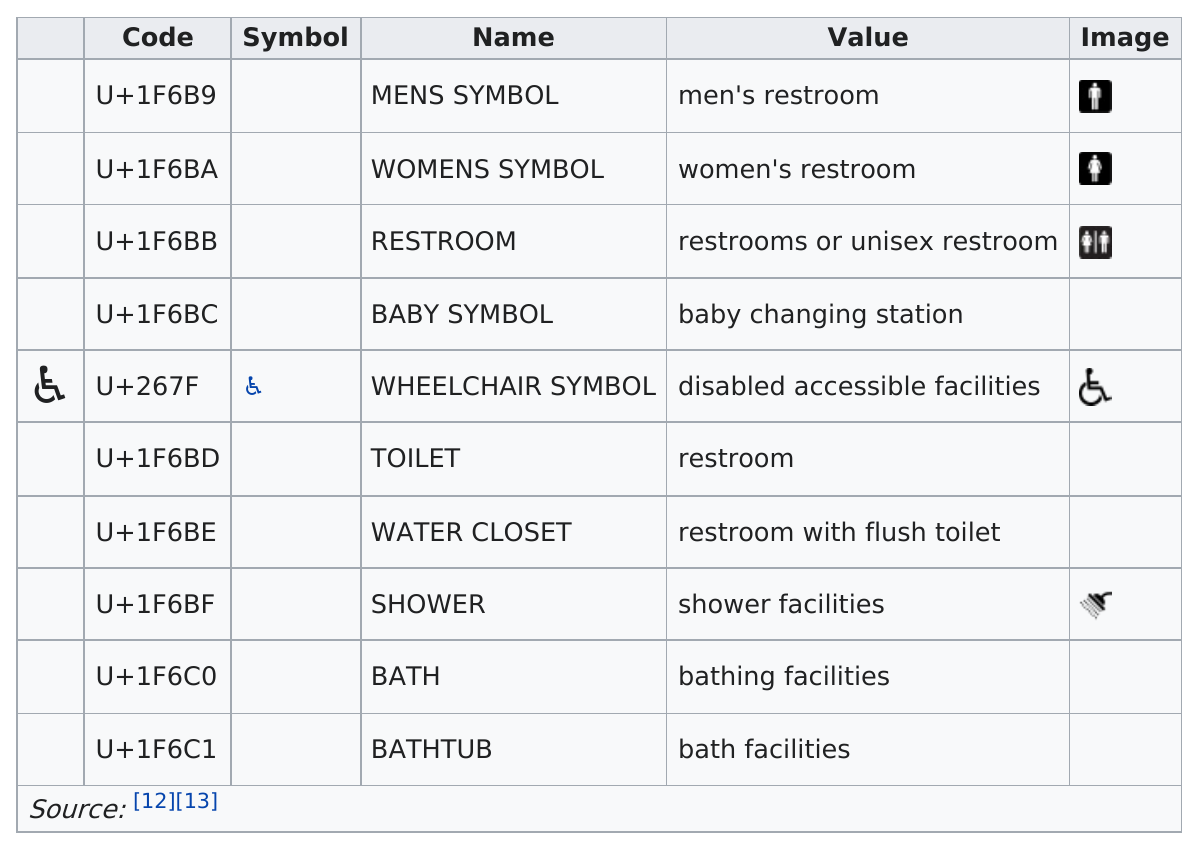Mention a couple of crucial points in this snapshot. The code for a unisex restroom is U+1F6BB. No, a water closet is not the same as a toilet. What is the code for shower facilities in Unicode? It is the emoji symbol represented by the sequence U+1F6BF. 